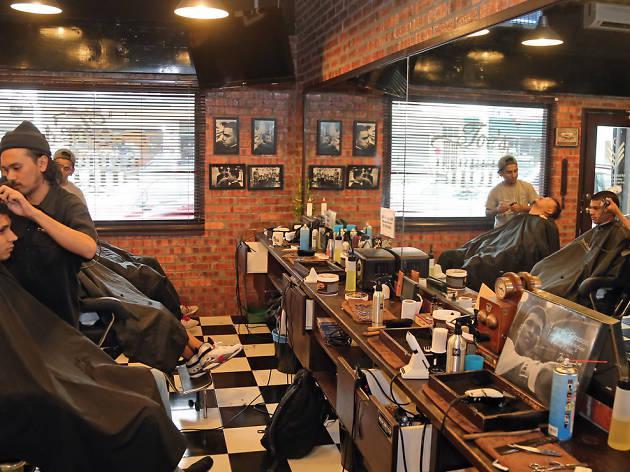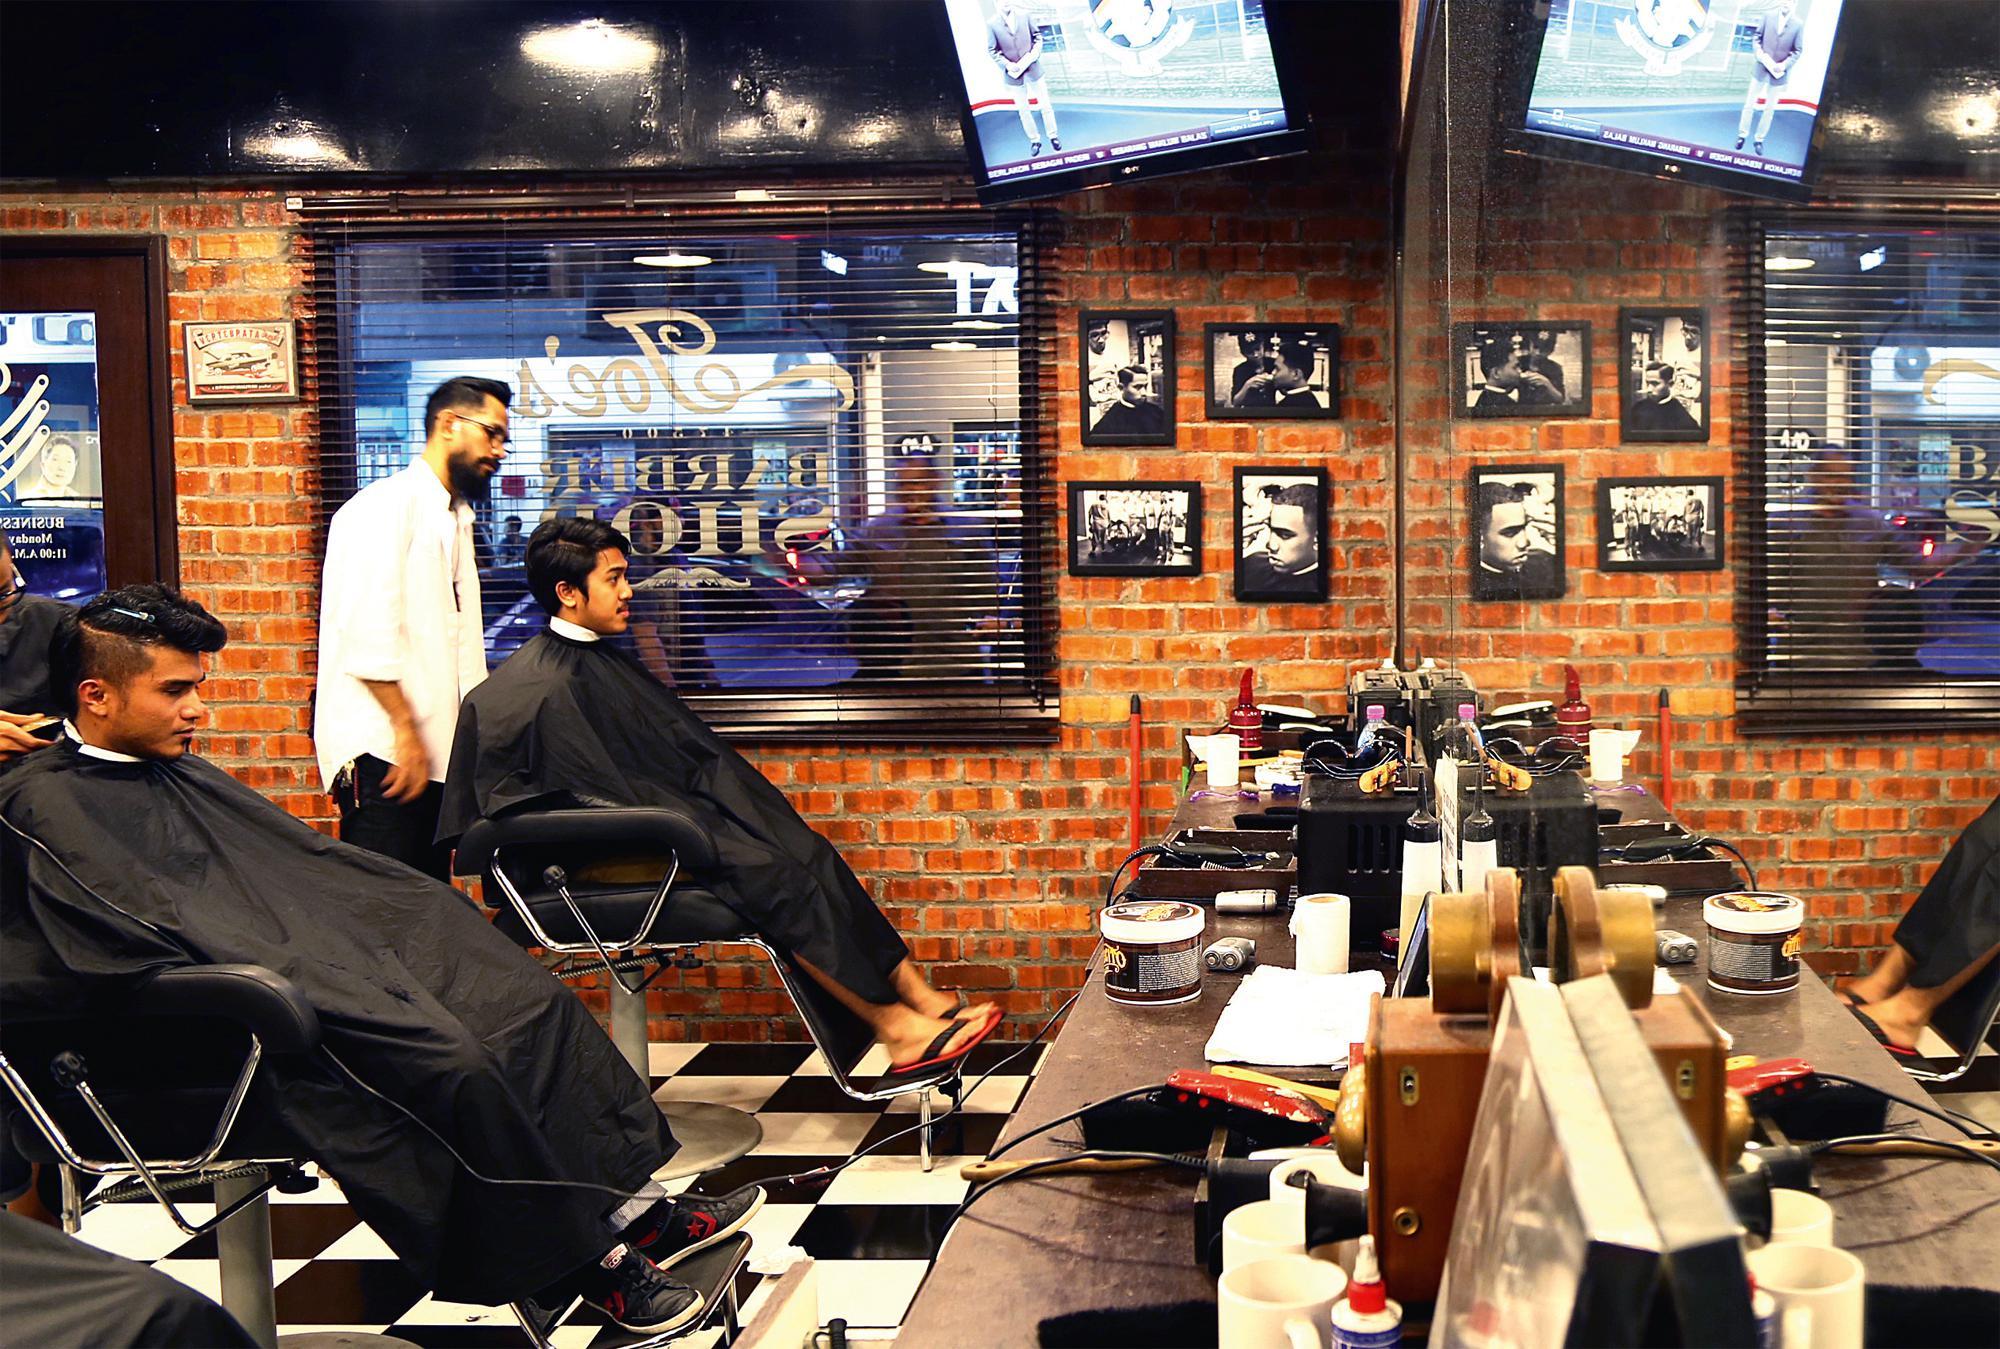The first image is the image on the left, the second image is the image on the right. Considering the images on both sides, is "There is a TV mounted high on the wall  in a barbershop with at least three barber chairs available to sit in." valid? Answer yes or no. No. The first image is the image on the left, the second image is the image on the right. Given the left and right images, does the statement "In the left image the person furthest to the left is cutting another persons hair that is seated in a barbers chair." hold true? Answer yes or no. Yes. 